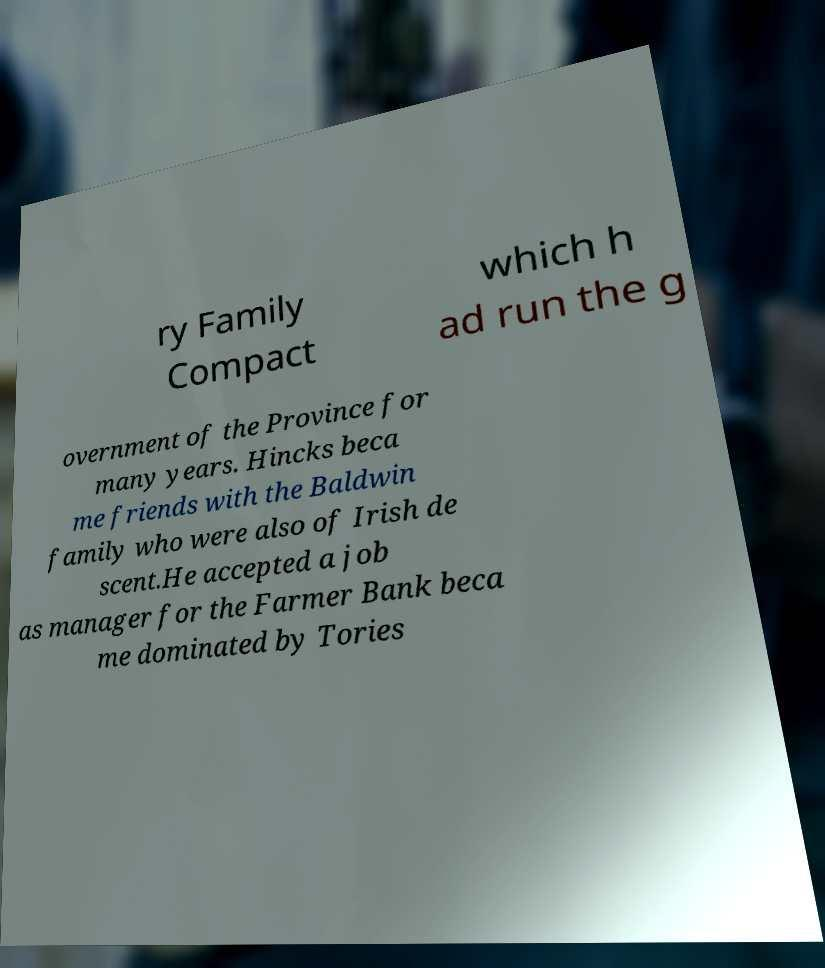Could you assist in decoding the text presented in this image and type it out clearly? ry Family Compact which h ad run the g overnment of the Province for many years. Hincks beca me friends with the Baldwin family who were also of Irish de scent.He accepted a job as manager for the Farmer Bank beca me dominated by Tories 